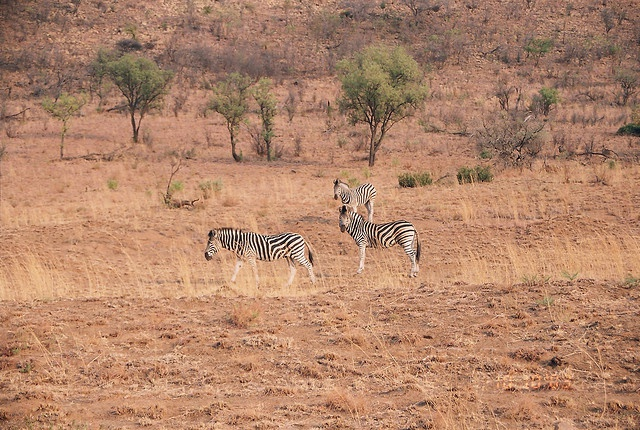Describe the objects in this image and their specific colors. I can see zebra in black, ivory, and tan tones, zebra in black, ivory, tan, and gray tones, and zebra in black, tan, ivory, and gray tones in this image. 